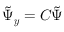<formula> <loc_0><loc_0><loc_500><loc_500>\tilde { \Psi } _ { y } = C \tilde { \Psi }</formula> 